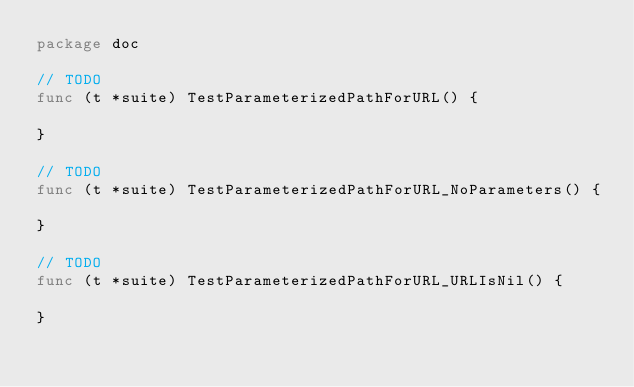<code> <loc_0><loc_0><loc_500><loc_500><_Go_>package doc

// TODO
func (t *suite) TestParameterizedPathForURL() {

}

// TODO
func (t *suite) TestParameterizedPathForURL_NoParameters() {

}

// TODO
func (t *suite) TestParameterizedPathForURL_URLIsNil() {

}
</code> 